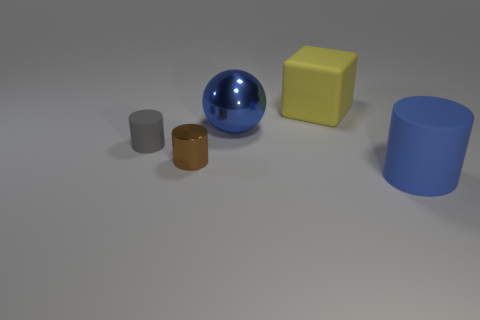Subtract all gray rubber cylinders. How many cylinders are left? 2 Add 4 small gray matte cylinders. How many objects exist? 9 Subtract all brown cylinders. How many cylinders are left? 2 Subtract all cylinders. How many objects are left? 2 Add 3 big cylinders. How many big cylinders are left? 4 Add 2 small yellow shiny balls. How many small yellow shiny balls exist? 2 Subtract 1 brown cylinders. How many objects are left? 4 Subtract 3 cylinders. How many cylinders are left? 0 Subtract all brown spheres. Subtract all yellow cylinders. How many spheres are left? 1 Subtract all tiny rubber cylinders. Subtract all big cylinders. How many objects are left? 3 